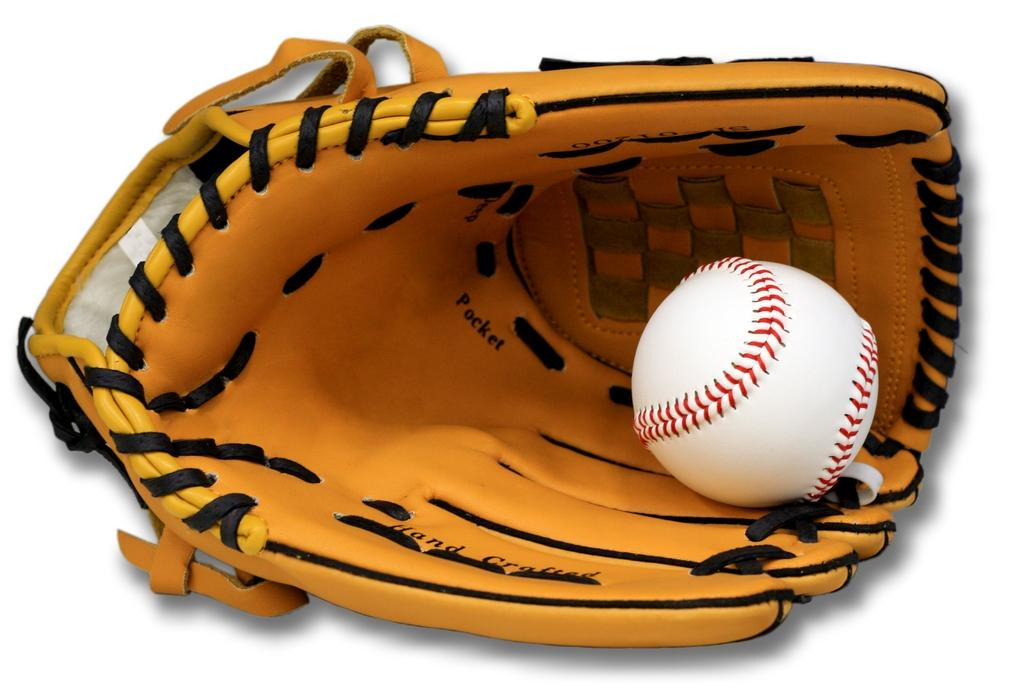What type of sports equipment is present in the image? There is a baseball glove in the image. What object is typically used with the baseball glove? There is a ball in the image, which is typically used with a baseball glove. What type of pipe can be seen in the design of the baseball glove? There is no pipe present in the image, nor is there any reference to a design that would include a pipe. 